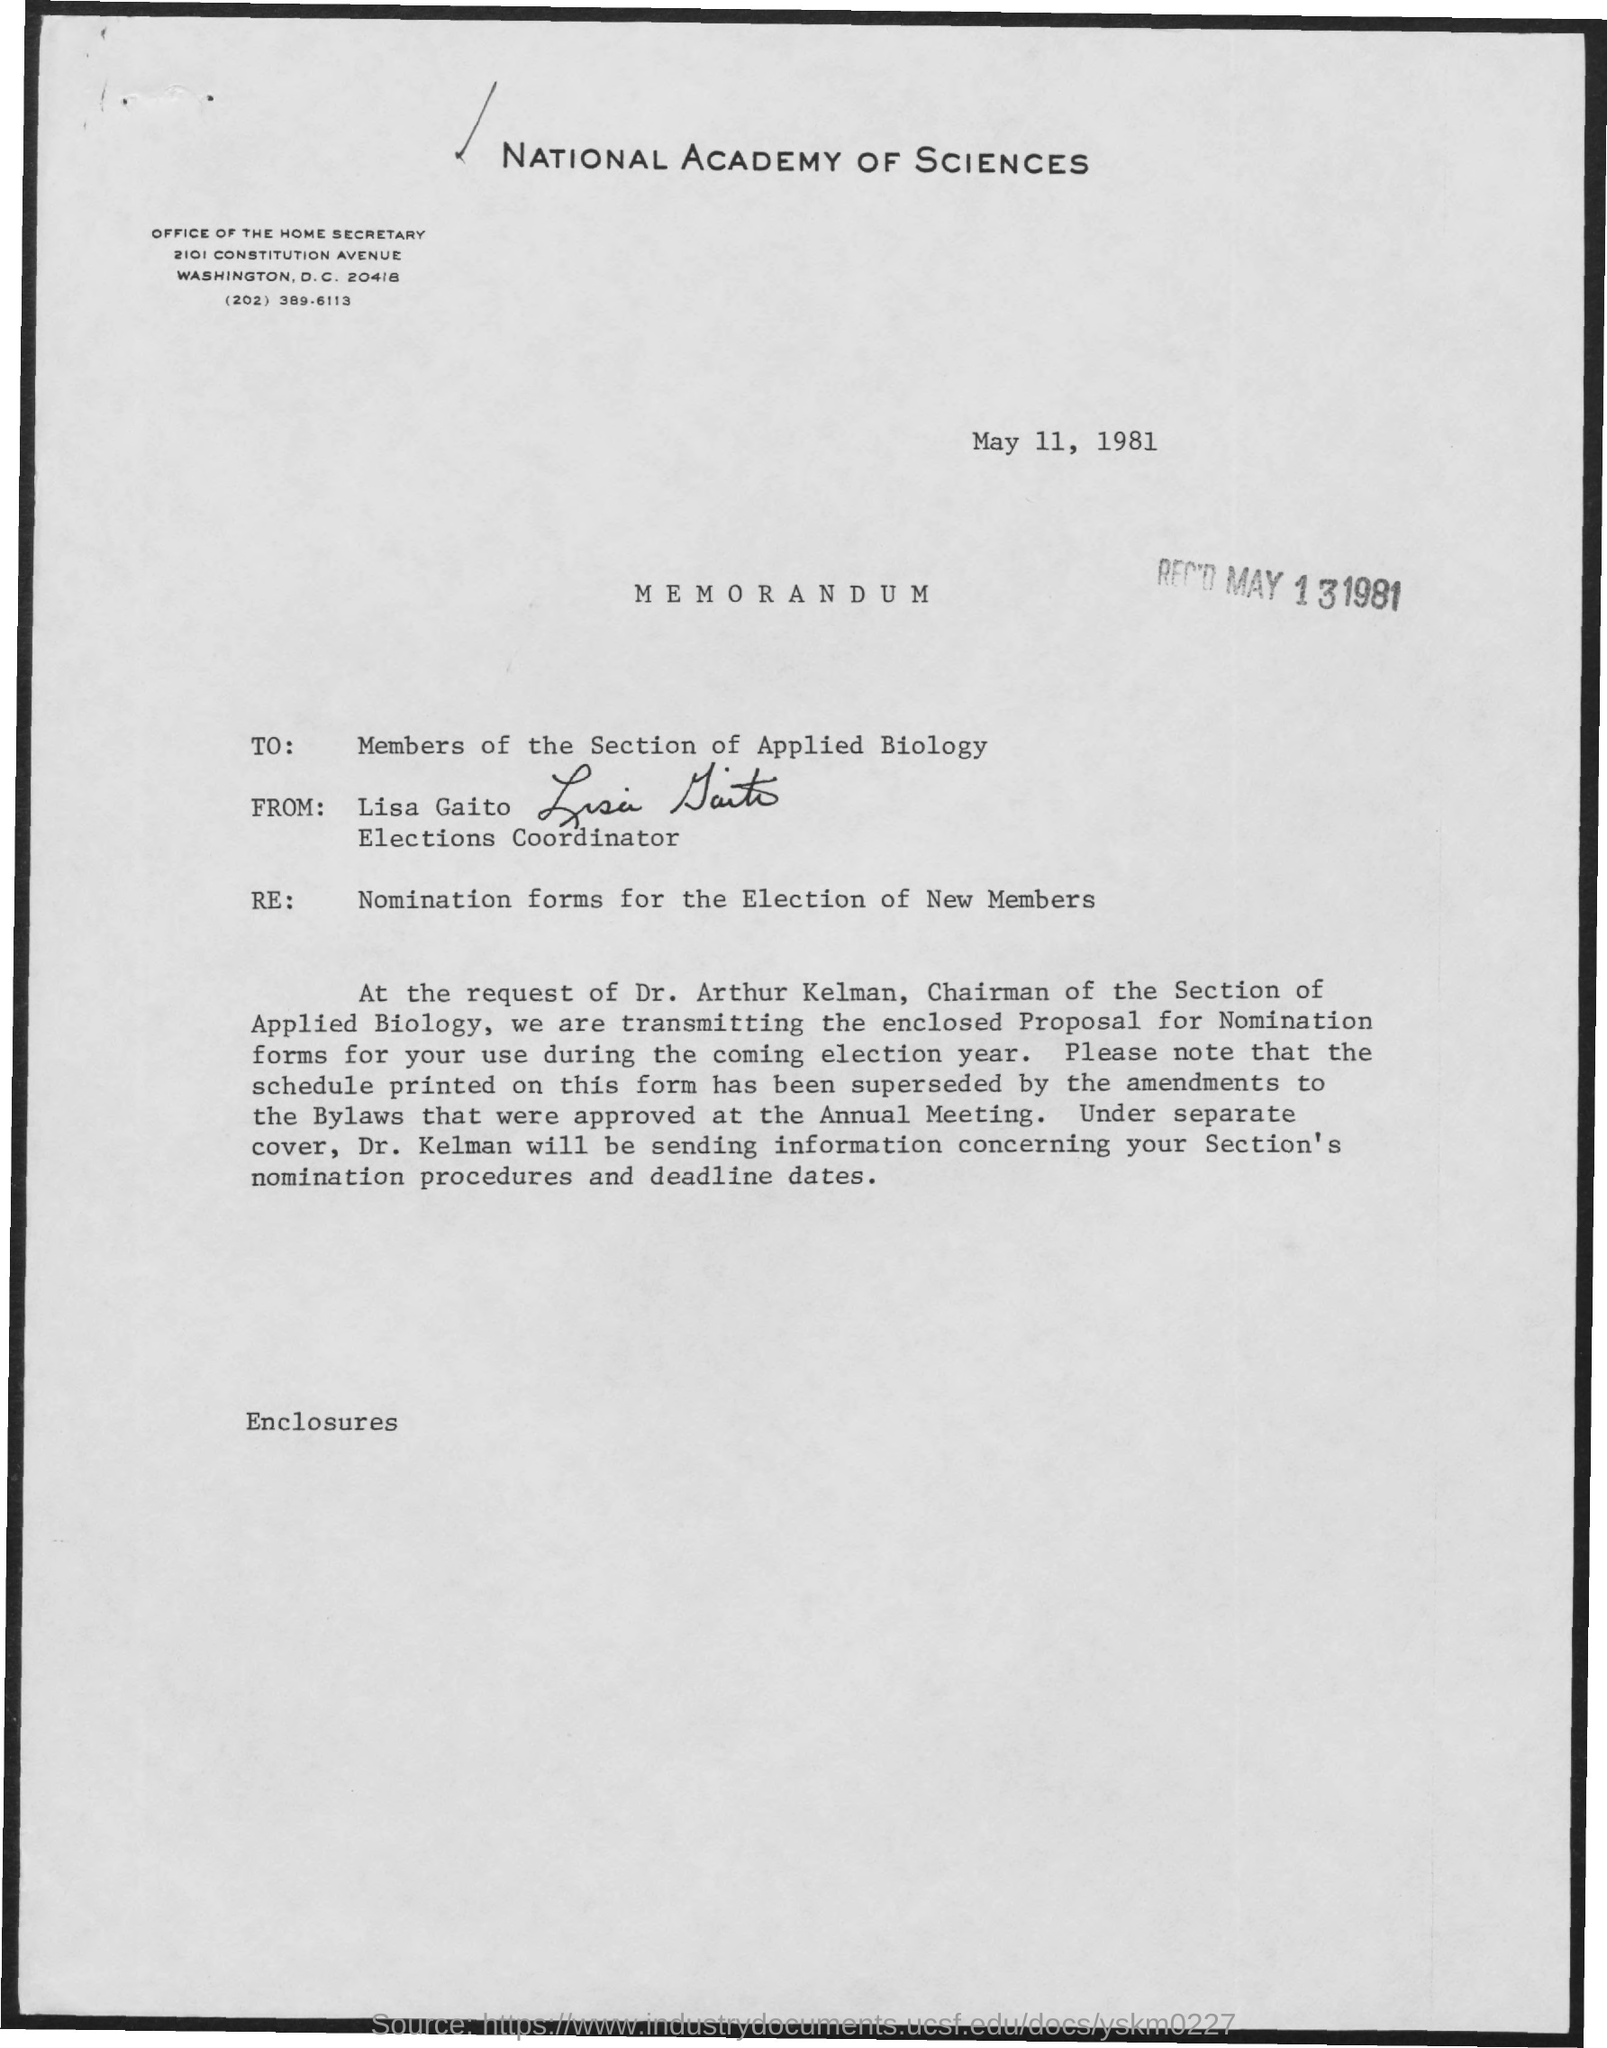Highlight a few significant elements in this photo. The person designated as the coordinator for the election is Lisa Gaito. The chairman of the section of applied biology is Dr. Arthur Kelman. The date of receipt is May 13, 1981. This letter is addressed to the members of the Section of Applied Biology. The sender of the letter is Lisa Gaito. 